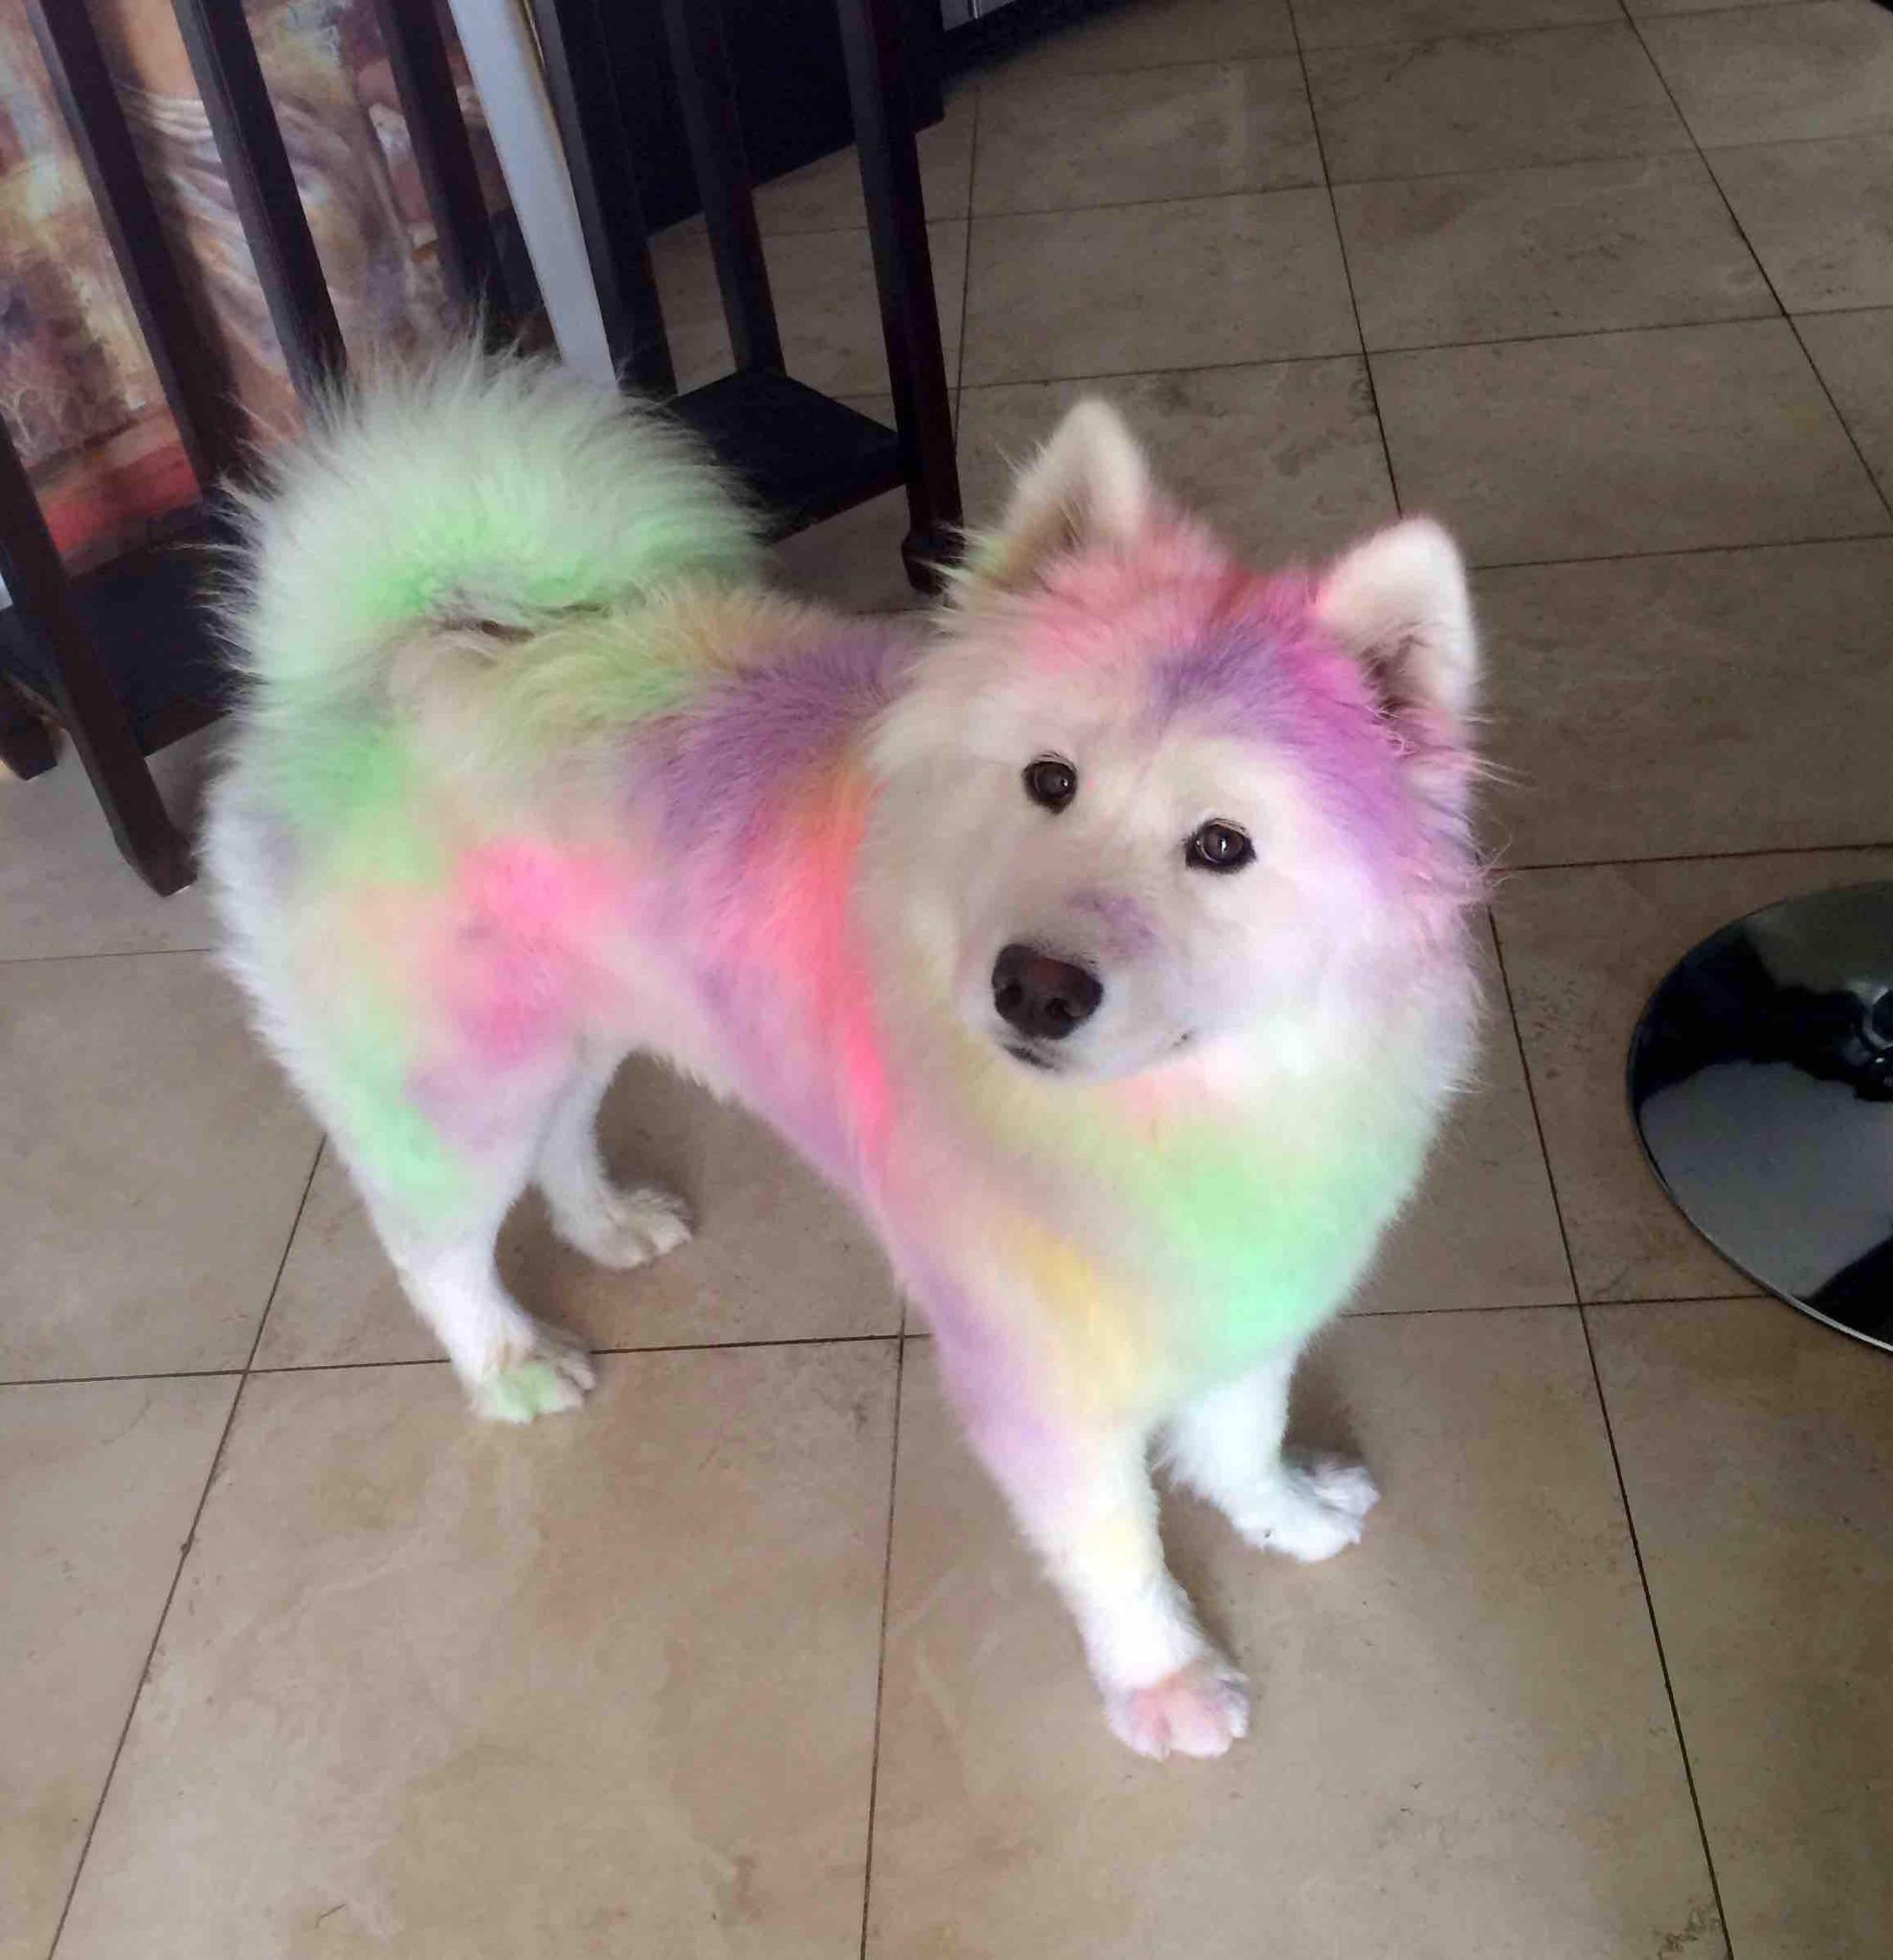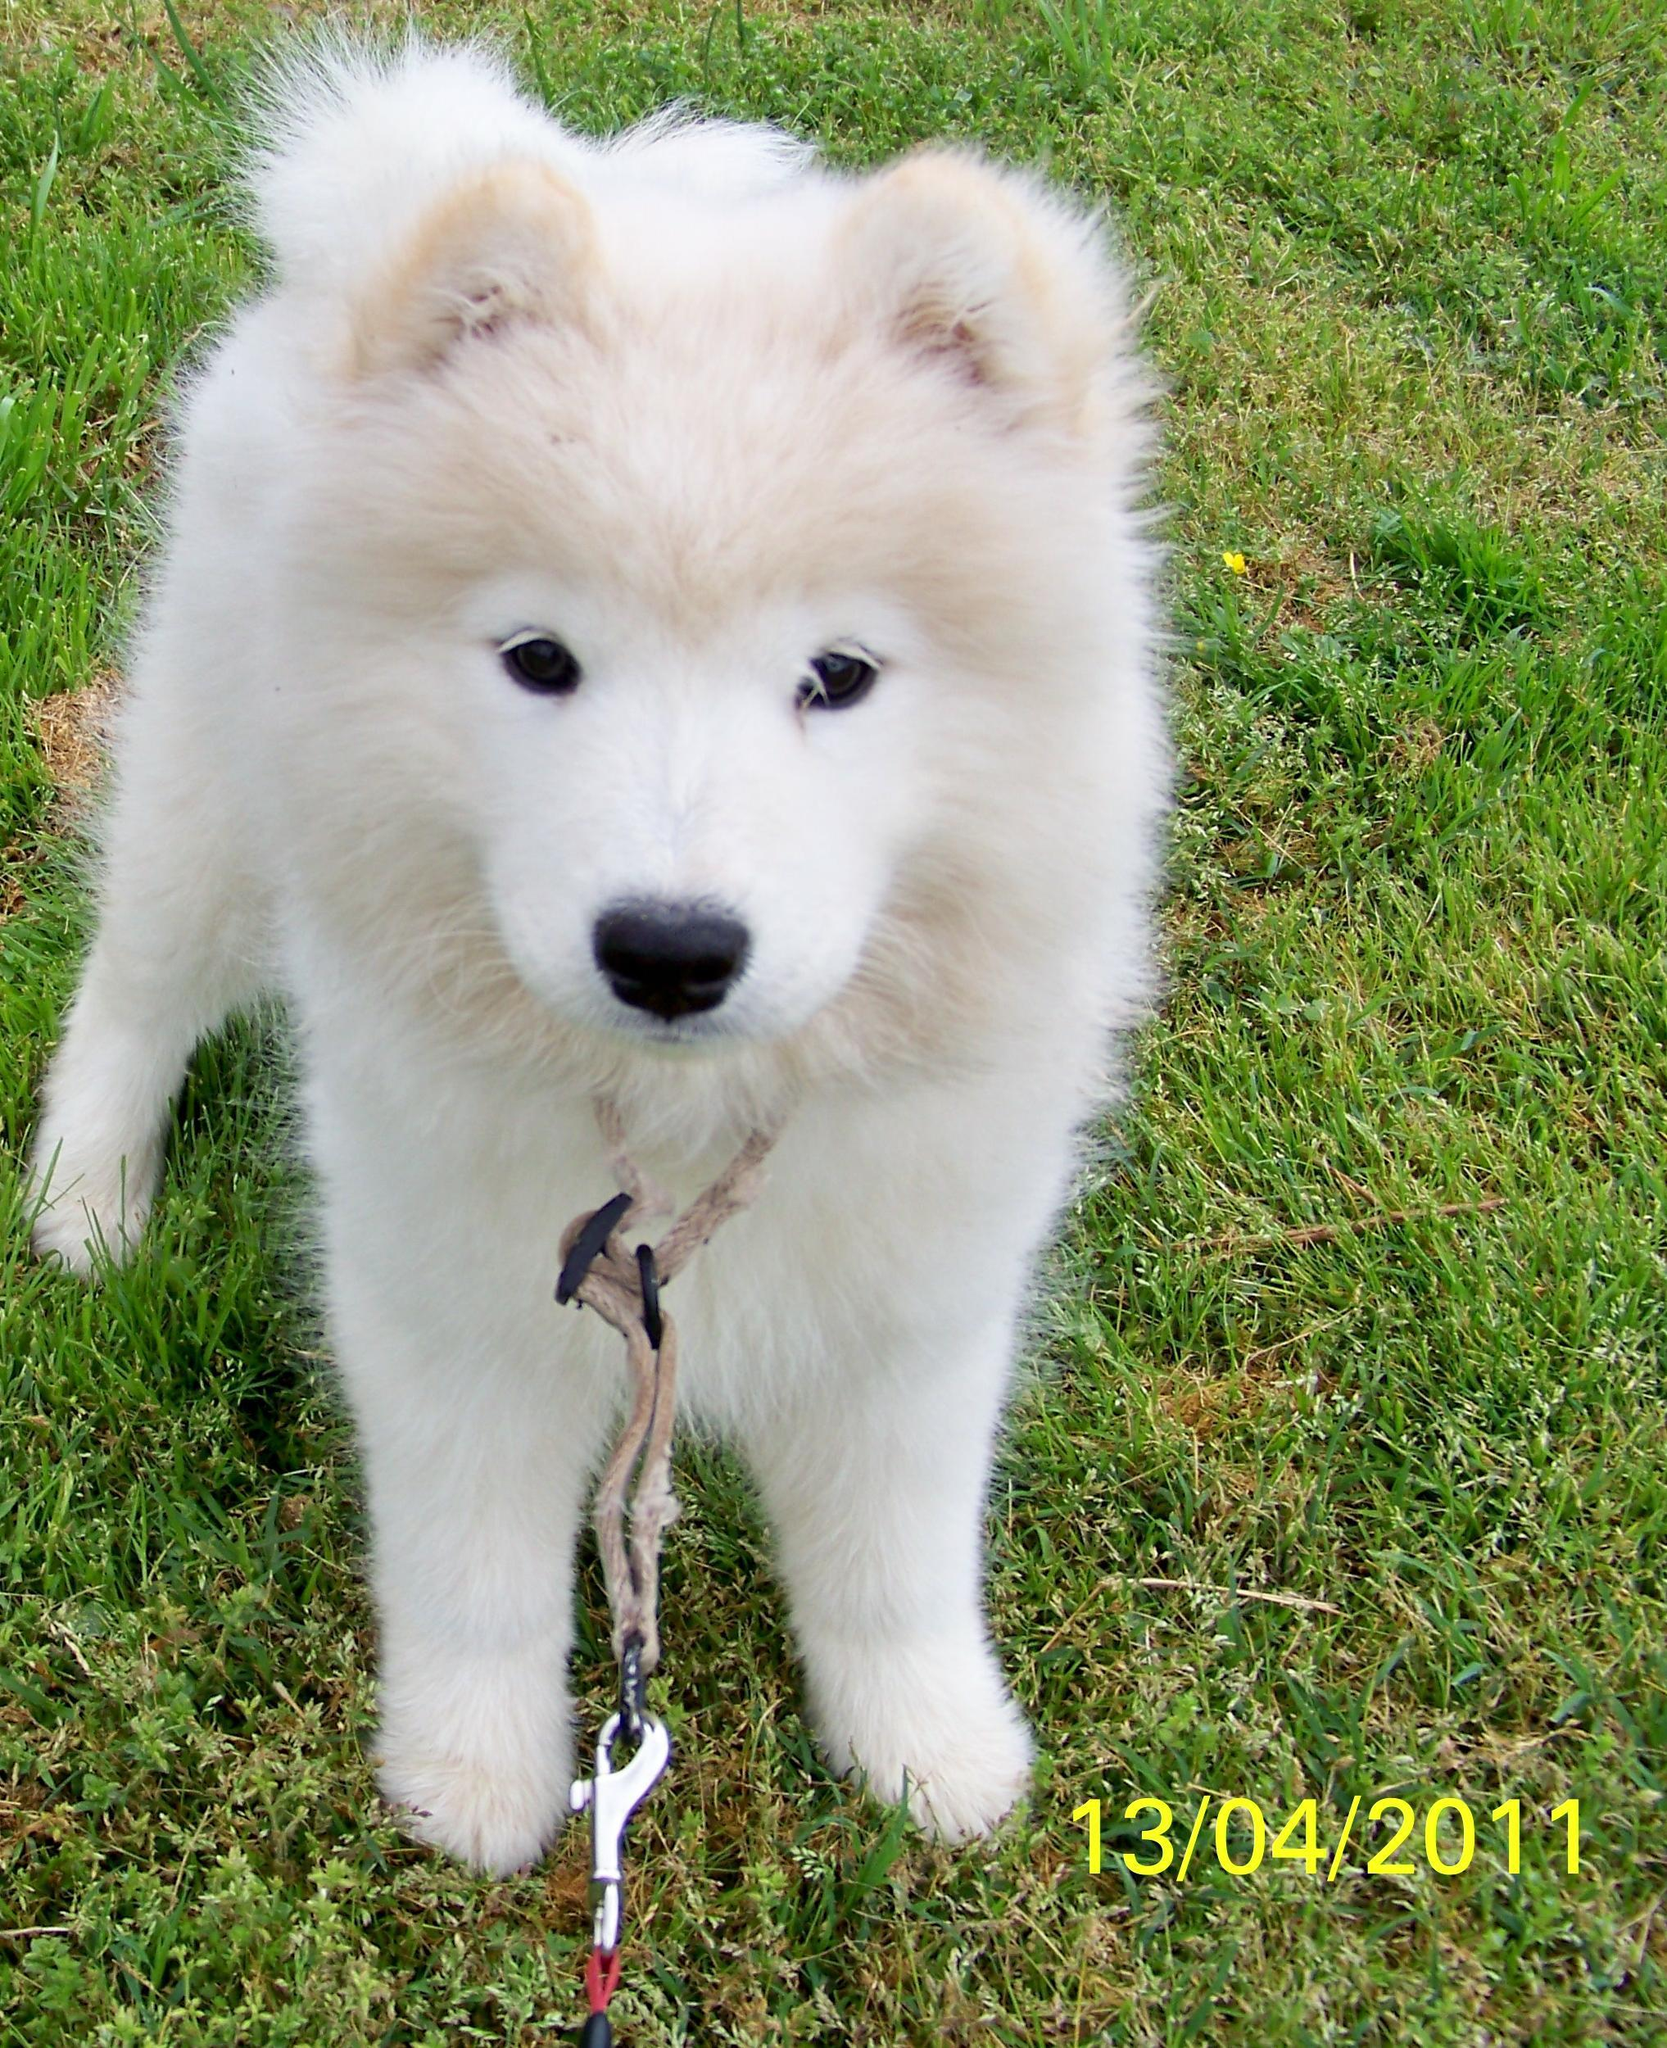The first image is the image on the left, the second image is the image on the right. Examine the images to the left and right. Is the description "Each image contains exactly one fluffy dog." accurate? Answer yes or no. Yes. The first image is the image on the left, the second image is the image on the right. For the images displayed, is the sentence "Both images contain a single dog." factually correct? Answer yes or no. Yes. 